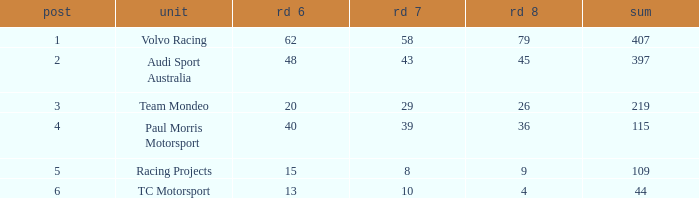What is the sum of values of Rd 7 with RD 6 less than 48 and Rd 8 less than 4 for TC Motorsport in a position greater than 1? None. 